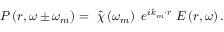<formula> <loc_0><loc_0><loc_500><loc_500>P \left ( r , \omega \pm \omega _ { m } \right ) = \ \hat { \chi } \left ( \omega _ { m } \right ) { \ e } ^ { i { k } _ { m } \cdot r } \ E \left ( r , \omega \right ) .</formula> 